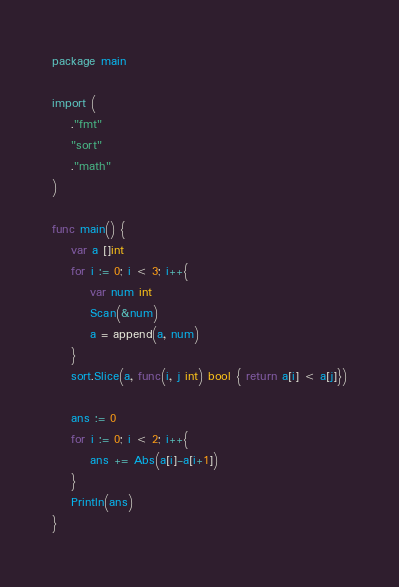<code> <loc_0><loc_0><loc_500><loc_500><_Go_>package main

import (
	."fmt"
	"sort"
	."math"
)

func main() {
	var a []int
	for i := 0; i < 3; i++{
		var num int
		Scan(&num)
		a = append(a, num)
	}
	sort.Slice(a, func(i, j int) bool { return a[i] < a[j]})

	ans := 0
	for i := 0; i < 2; i++{
		ans += Abs(a[i]-a[i+1]) 
	}
	Println(ans)
}
</code> 